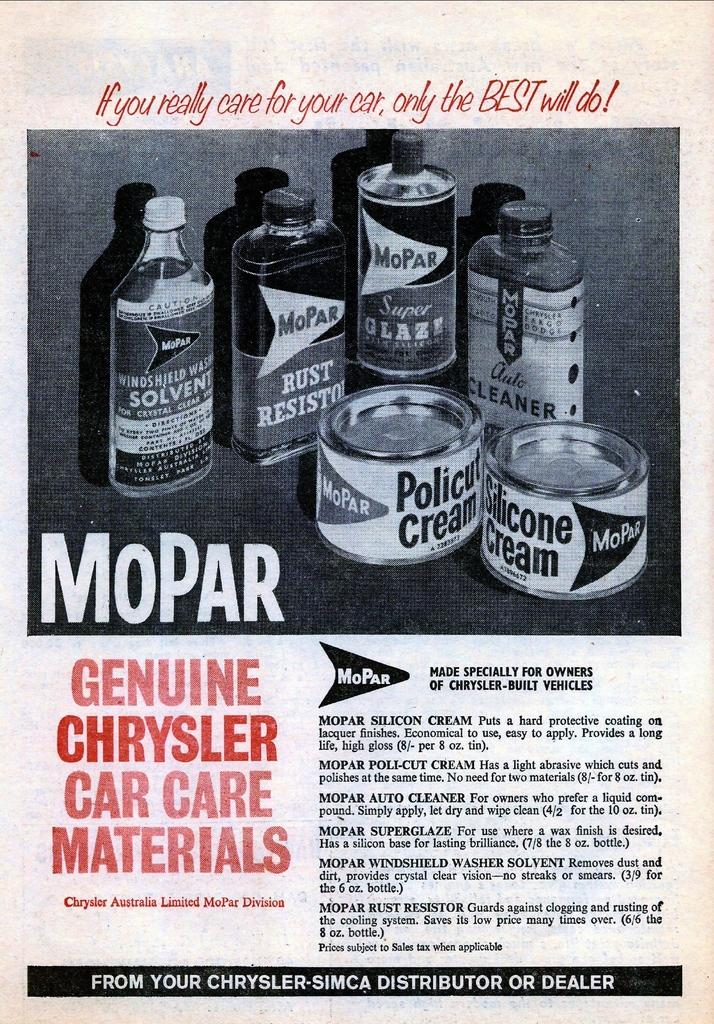<image>
Share a concise interpretation of the image provided. The materials shown are genuine materials for a Chrysler. 